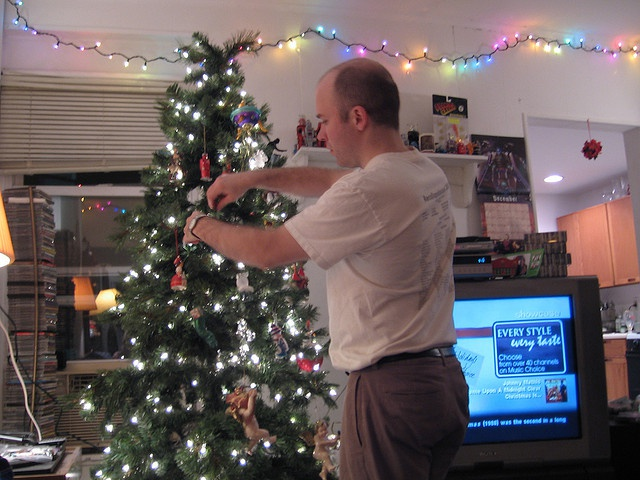Describe the objects in this image and their specific colors. I can see people in gray, brown, black, and darkgray tones and tv in gray, black, lightblue, and blue tones in this image. 